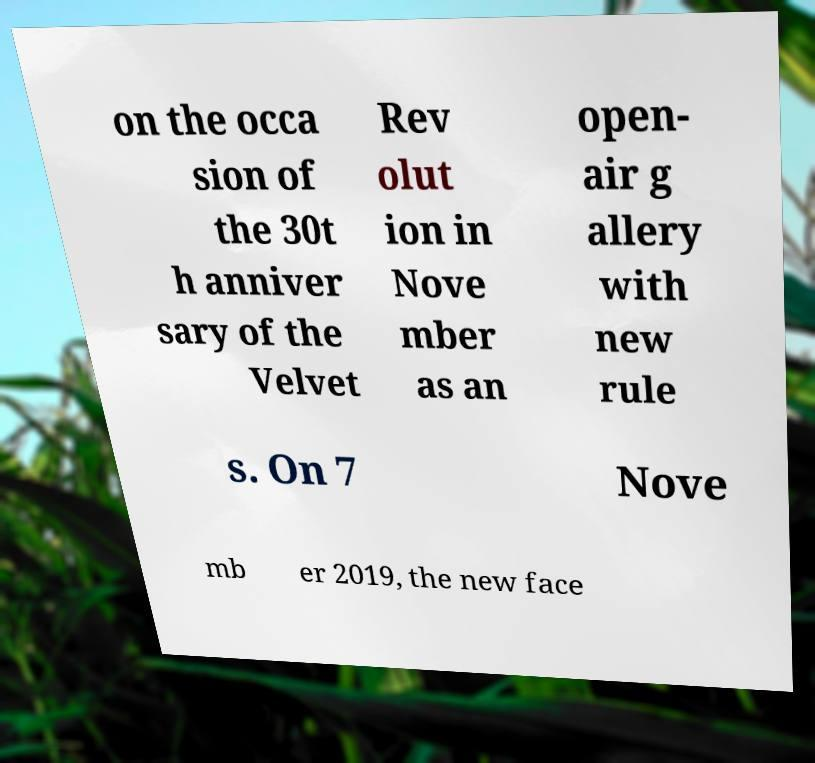I need the written content from this picture converted into text. Can you do that? on the occa sion of the 30t h anniver sary of the Velvet Rev olut ion in Nove mber as an open- air g allery with new rule s. On 7 Nove mb er 2019, the new face 